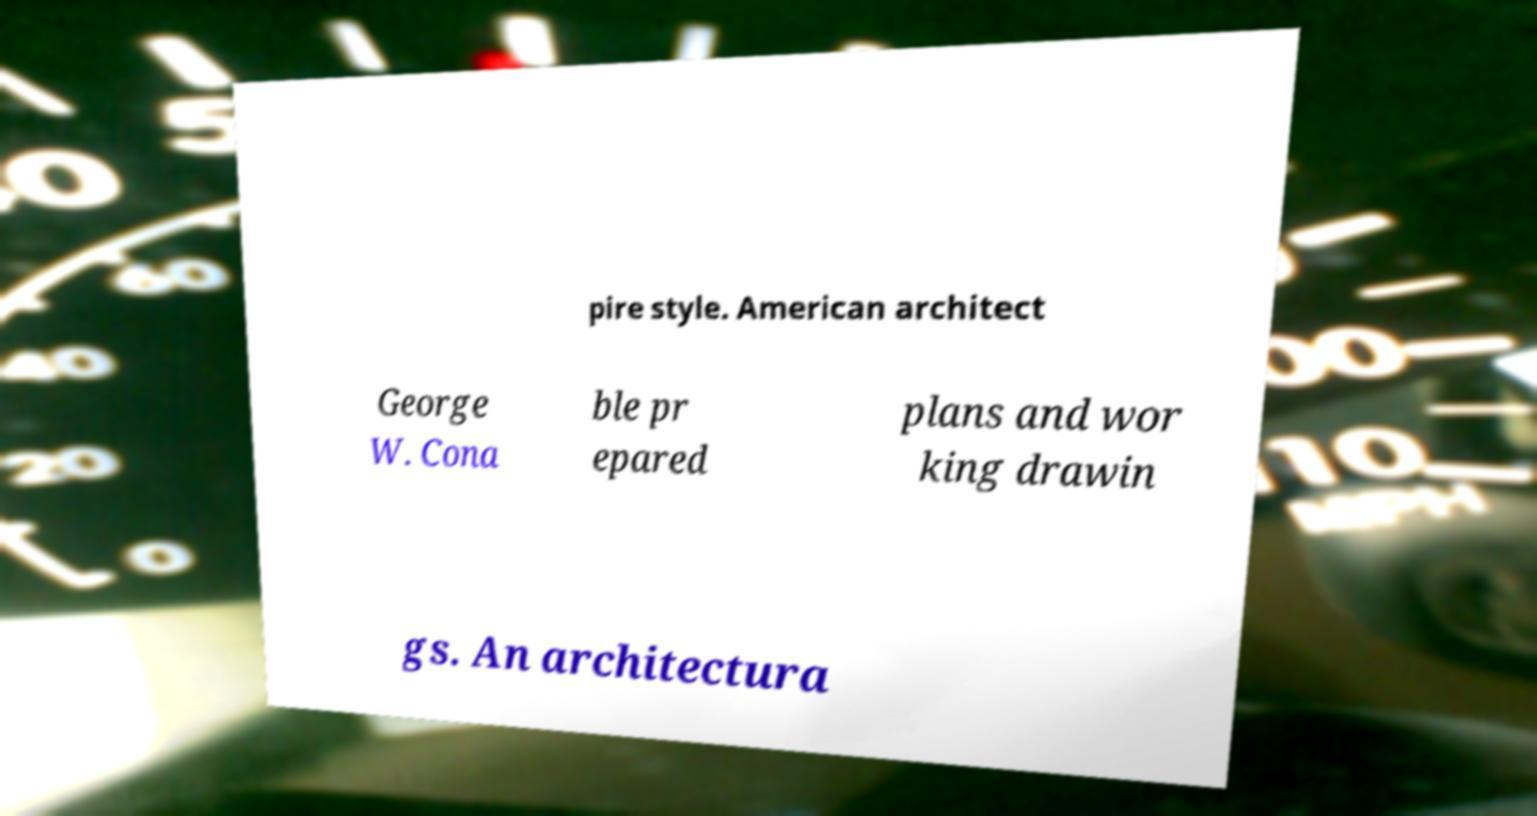For documentation purposes, I need the text within this image transcribed. Could you provide that? pire style. American architect George W. Cona ble pr epared plans and wor king drawin gs. An architectura 